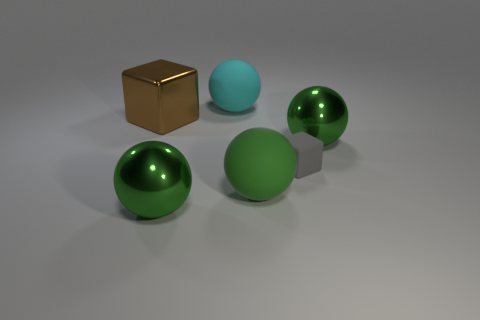Subtract all gray cylinders. How many green spheres are left? 3 Add 1 small red metal balls. How many objects exist? 7 Subtract all spheres. How many objects are left? 2 Subtract 0 yellow cylinders. How many objects are left? 6 Subtract all green matte objects. Subtract all big shiny things. How many objects are left? 2 Add 1 small gray rubber blocks. How many small gray rubber blocks are left? 2 Add 6 balls. How many balls exist? 10 